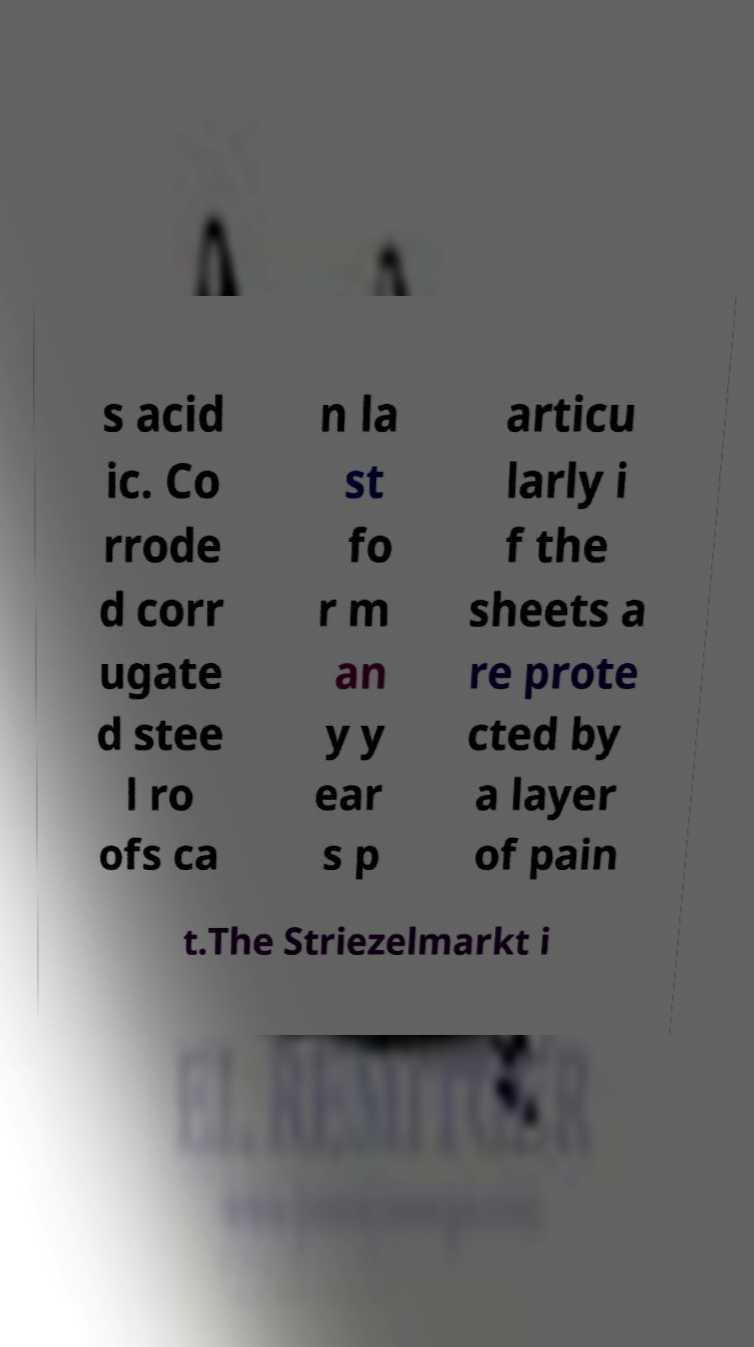What messages or text are displayed in this image? I need them in a readable, typed format. s acid ic. Co rrode d corr ugate d stee l ro ofs ca n la st fo r m an y y ear s p articu larly i f the sheets a re prote cted by a layer of pain t.The Striezelmarkt i 